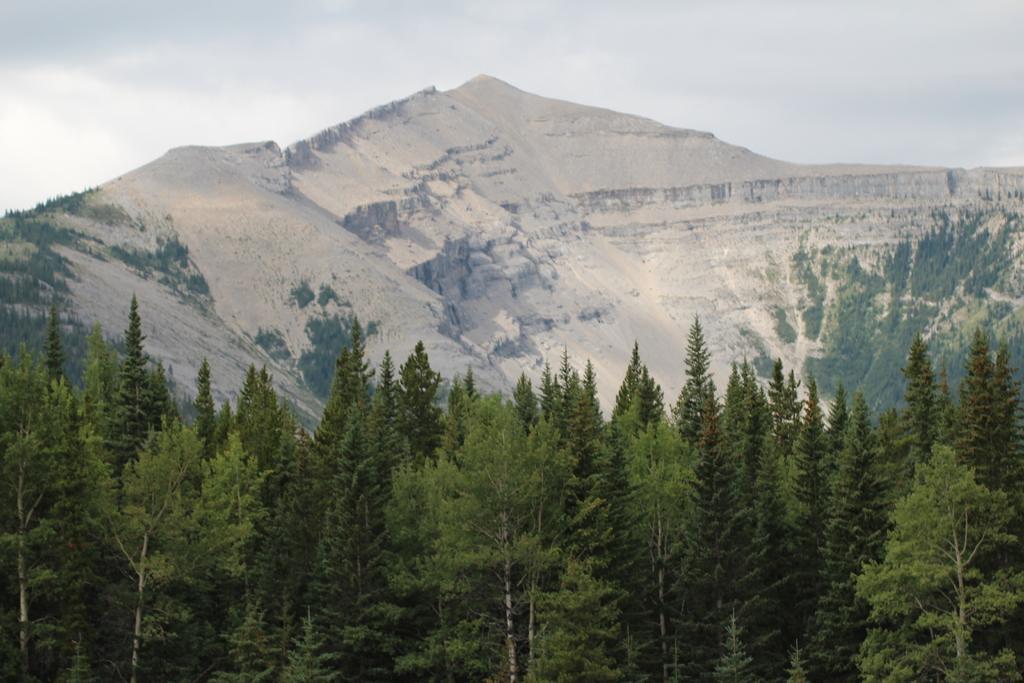Describe this image in one or two sentences. In the picture there is a thicket and behind the thicket there is a mountain. 